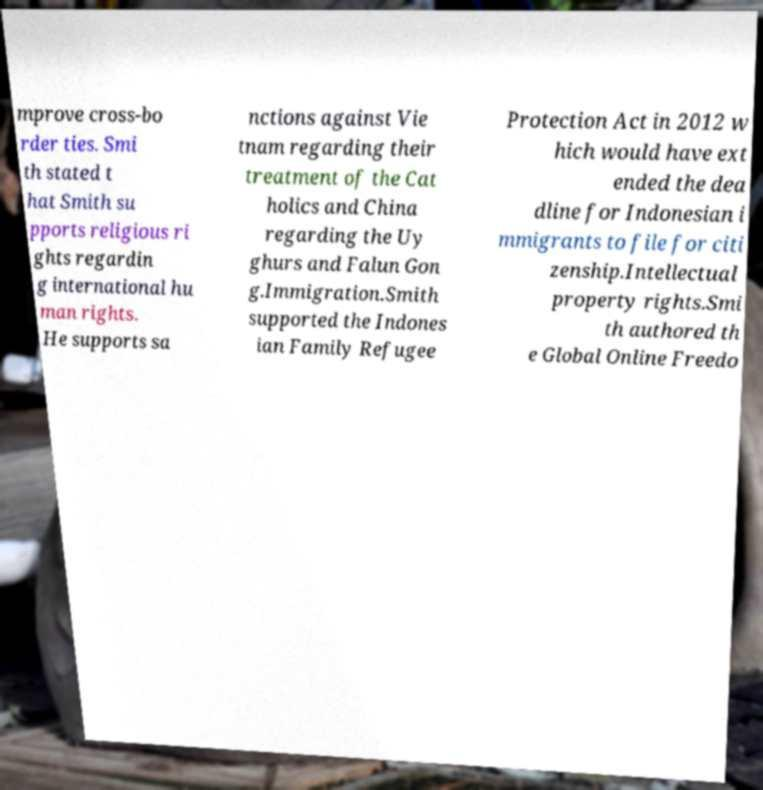Can you read and provide the text displayed in the image?This photo seems to have some interesting text. Can you extract and type it out for me? mprove cross-bo rder ties. Smi th stated t hat Smith su pports religious ri ghts regardin g international hu man rights. He supports sa nctions against Vie tnam regarding their treatment of the Cat holics and China regarding the Uy ghurs and Falun Gon g.Immigration.Smith supported the Indones ian Family Refugee Protection Act in 2012 w hich would have ext ended the dea dline for Indonesian i mmigrants to file for citi zenship.Intellectual property rights.Smi th authored th e Global Online Freedo 